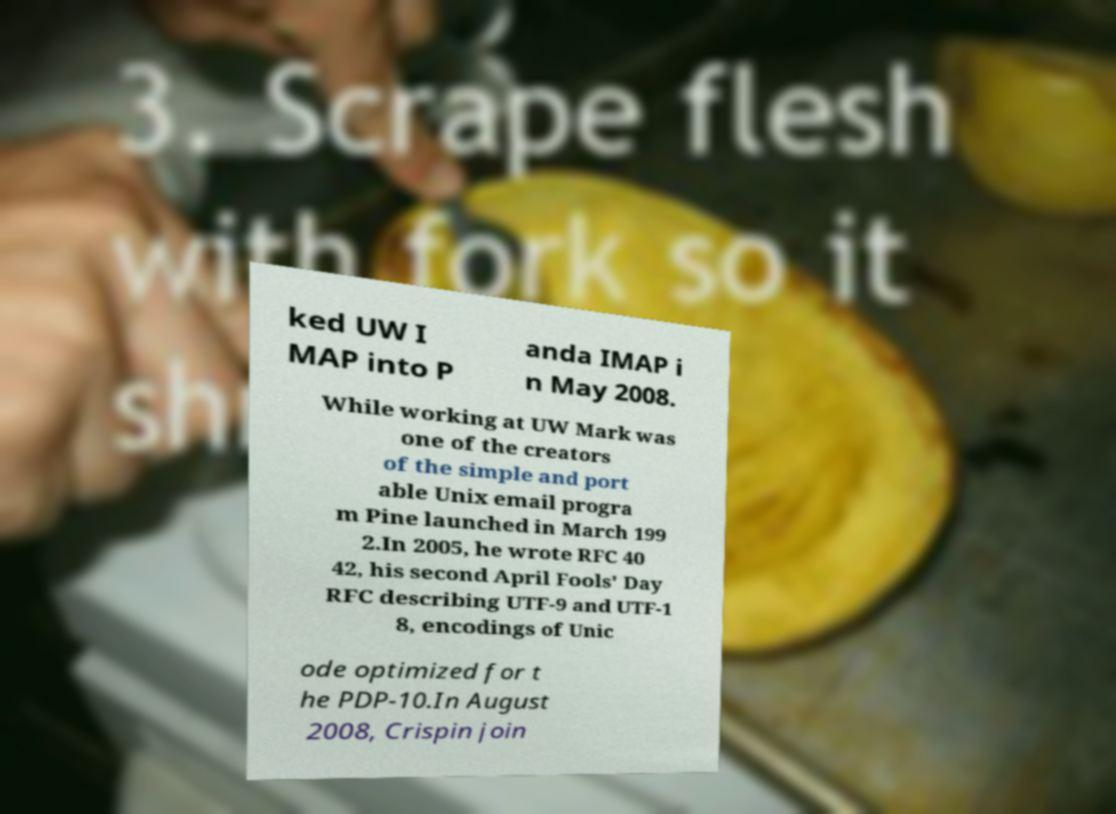Could you assist in decoding the text presented in this image and type it out clearly? ked UW I MAP into P anda IMAP i n May 2008. While working at UW Mark was one of the creators of the simple and port able Unix email progra m Pine launched in March 199 2.In 2005, he wrote RFC 40 42, his second April Fools' Day RFC describing UTF-9 and UTF-1 8, encodings of Unic ode optimized for t he PDP-10.In August 2008, Crispin join 